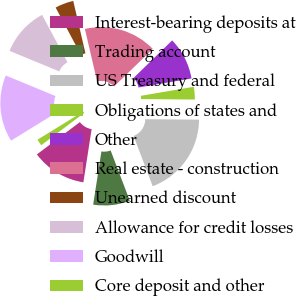Convert chart. <chart><loc_0><loc_0><loc_500><loc_500><pie_chart><fcel>Interest-bearing deposits at<fcel>Trading account<fcel>US Treasury and federal<fcel>Obligations of states and<fcel>Other<fcel>Real estate - construction<fcel>Unearned discount<fcel>Allowance for credit losses<fcel>Goodwill<fcel>Core deposit and other<nl><fcel>12.3%<fcel>8.24%<fcel>19.07%<fcel>2.83%<fcel>9.59%<fcel>16.36%<fcel>4.18%<fcel>10.95%<fcel>15.01%<fcel>1.47%<nl></chart> 